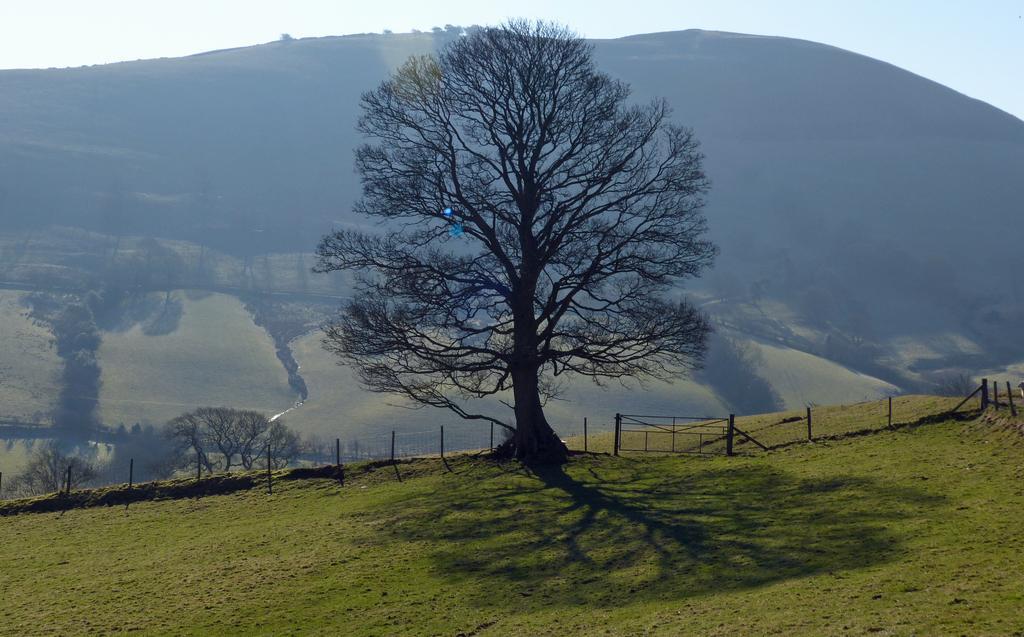Please provide a concise description of this image. In this image there are trees. There is a wooden fence. There are poles. At the bottom of the image there is grass on the surface. In the background of the image there are mountains. At the top of the image there is sky. 